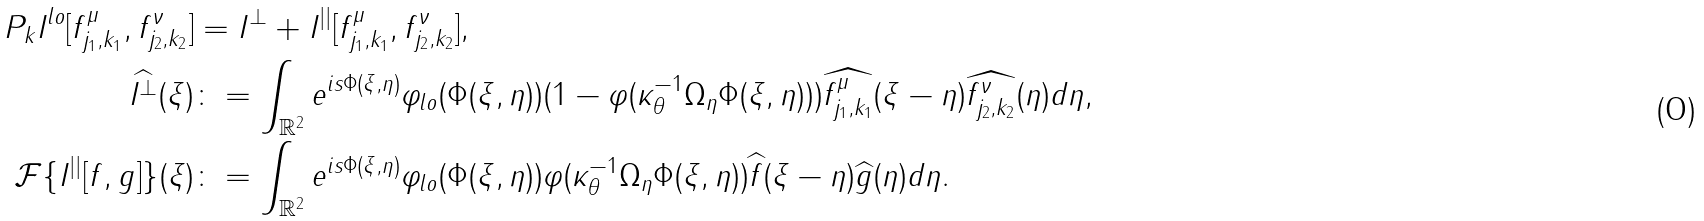<formula> <loc_0><loc_0><loc_500><loc_500>P _ { k } I ^ { l o } [ f ^ { \mu } _ { j _ { 1 } , k _ { 1 } } , f ^ { \nu } _ { j _ { 2 } , k _ { 2 } } ] & = I ^ { \perp } + I ^ { | | } [ f ^ { \mu } _ { j _ { 1 } , k _ { 1 } } , f ^ { \nu } _ { j _ { 2 } , k _ { 2 } } ] , \\ \widehat { I ^ { \perp } } ( \xi ) & \colon = \int _ { \mathbb { R } ^ { 2 } } e ^ { i s \Phi ( \xi , \eta ) } \varphi _ { l o } ( \Phi ( \xi , \eta ) ) ( 1 - \varphi ( \kappa _ { \theta } ^ { - 1 } \Omega _ { \eta } \Phi ( \xi , \eta ) ) ) \widehat { f ^ { \mu } _ { j _ { 1 } , k _ { 1 } } } ( \xi - \eta ) \widehat { f ^ { \nu } _ { j _ { 2 } , k _ { 2 } } } ( \eta ) d \eta , \\ \mathcal { F } \{ I ^ { | | } [ f , g ] \} ( \xi ) & \colon = \int _ { \mathbb { R } ^ { 2 } } e ^ { i s \Phi ( \xi , \eta ) } \varphi _ { l o } ( \Phi ( \xi , \eta ) ) \varphi ( \kappa _ { \theta } ^ { - 1 } \Omega _ { \eta } \Phi ( \xi , \eta ) ) \widehat { f } ( \xi - \eta ) \widehat { g } ( \eta ) d \eta . \\</formula> 